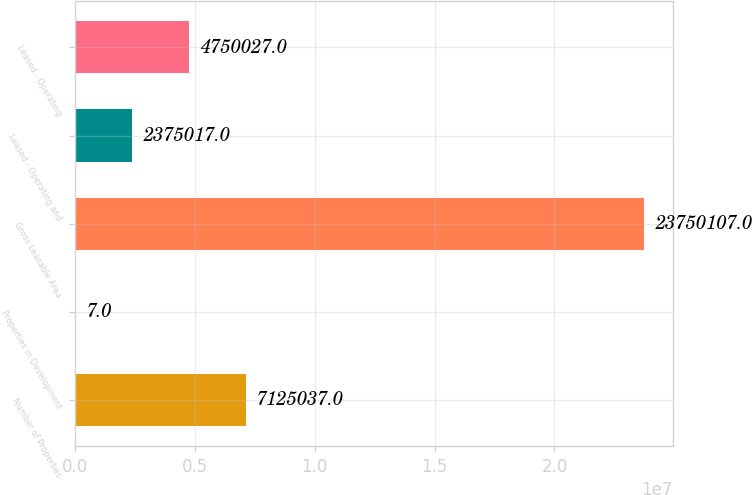<chart> <loc_0><loc_0><loc_500><loc_500><bar_chart><fcel>Number of Properties<fcel>Properties in Development<fcel>Gross Leasable Area<fcel>Leased - Operating and<fcel>Leased - Operating<nl><fcel>7.12504e+06<fcel>7<fcel>2.37501e+07<fcel>2.37502e+06<fcel>4.75003e+06<nl></chart> 